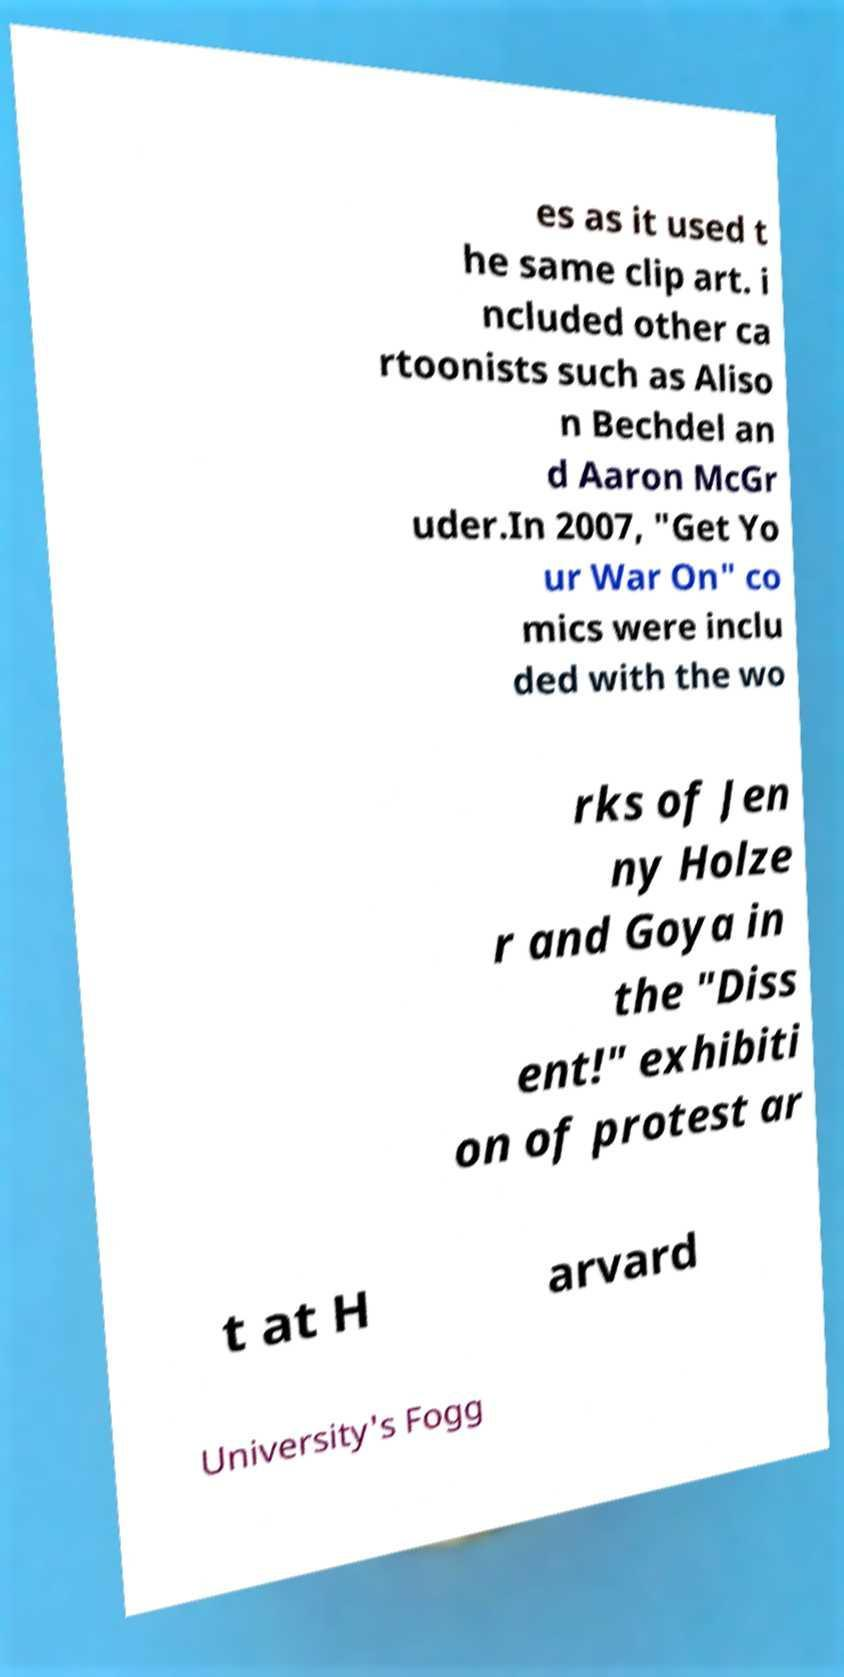Can you accurately transcribe the text from the provided image for me? es as it used t he same clip art. i ncluded other ca rtoonists such as Aliso n Bechdel an d Aaron McGr uder.In 2007, "Get Yo ur War On" co mics were inclu ded with the wo rks of Jen ny Holze r and Goya in the "Diss ent!" exhibiti on of protest ar t at H arvard University's Fogg 